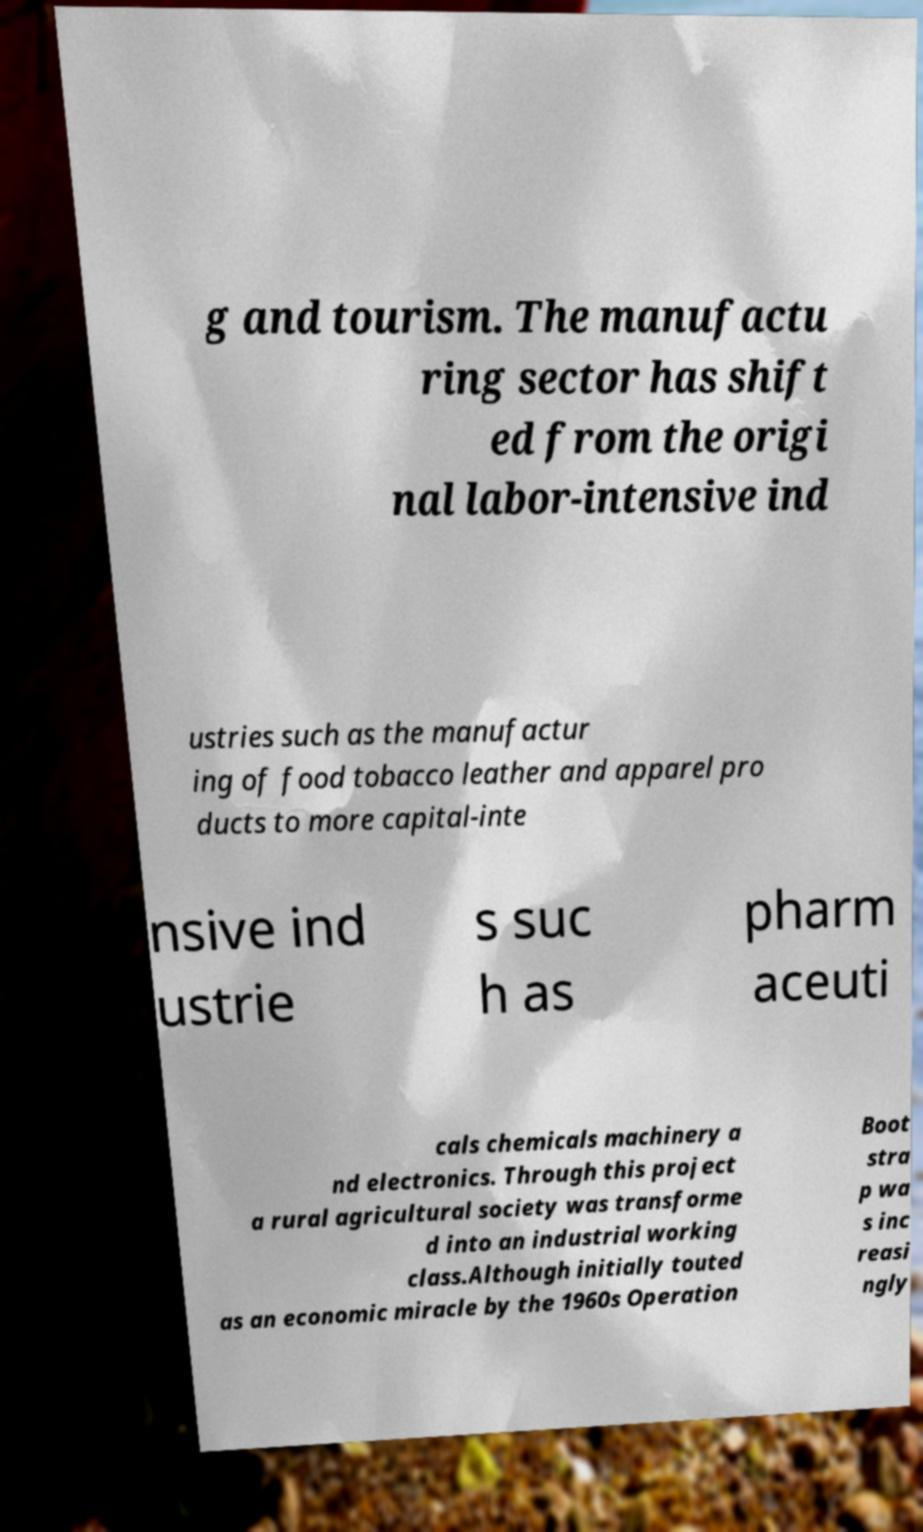Could you assist in decoding the text presented in this image and type it out clearly? g and tourism. The manufactu ring sector has shift ed from the origi nal labor-intensive ind ustries such as the manufactur ing of food tobacco leather and apparel pro ducts to more capital-inte nsive ind ustrie s suc h as pharm aceuti cals chemicals machinery a nd electronics. Through this project a rural agricultural society was transforme d into an industrial working class.Although initially touted as an economic miracle by the 1960s Operation Boot stra p wa s inc reasi ngly 